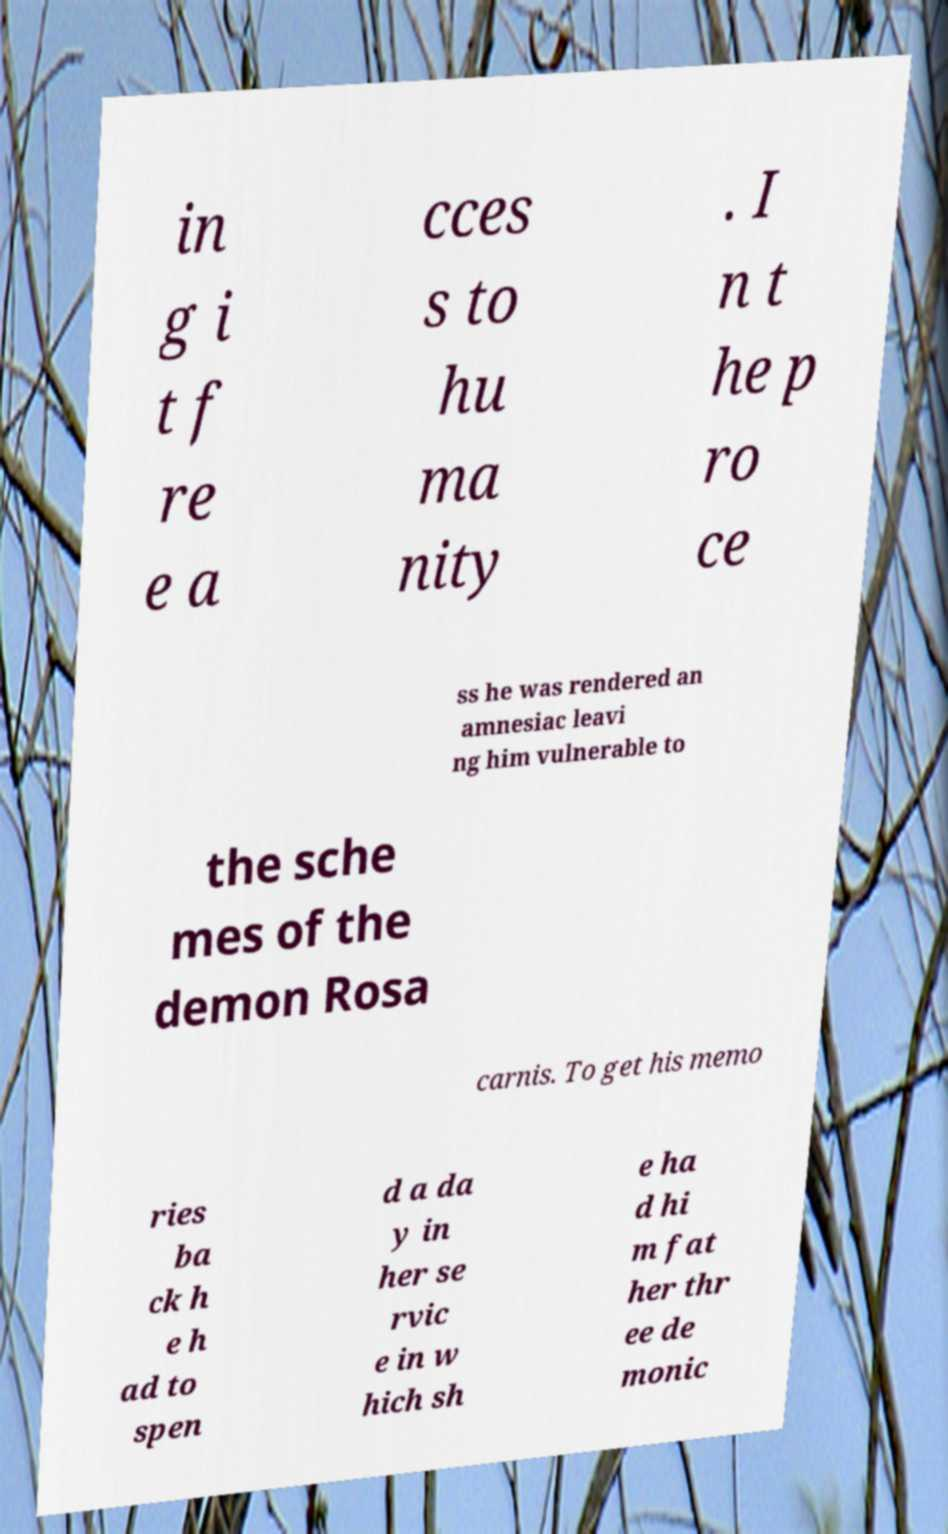I need the written content from this picture converted into text. Can you do that? in g i t f re e a cces s to hu ma nity . I n t he p ro ce ss he was rendered an amnesiac leavi ng him vulnerable to the sche mes of the demon Rosa carnis. To get his memo ries ba ck h e h ad to spen d a da y in her se rvic e in w hich sh e ha d hi m fat her thr ee de monic 